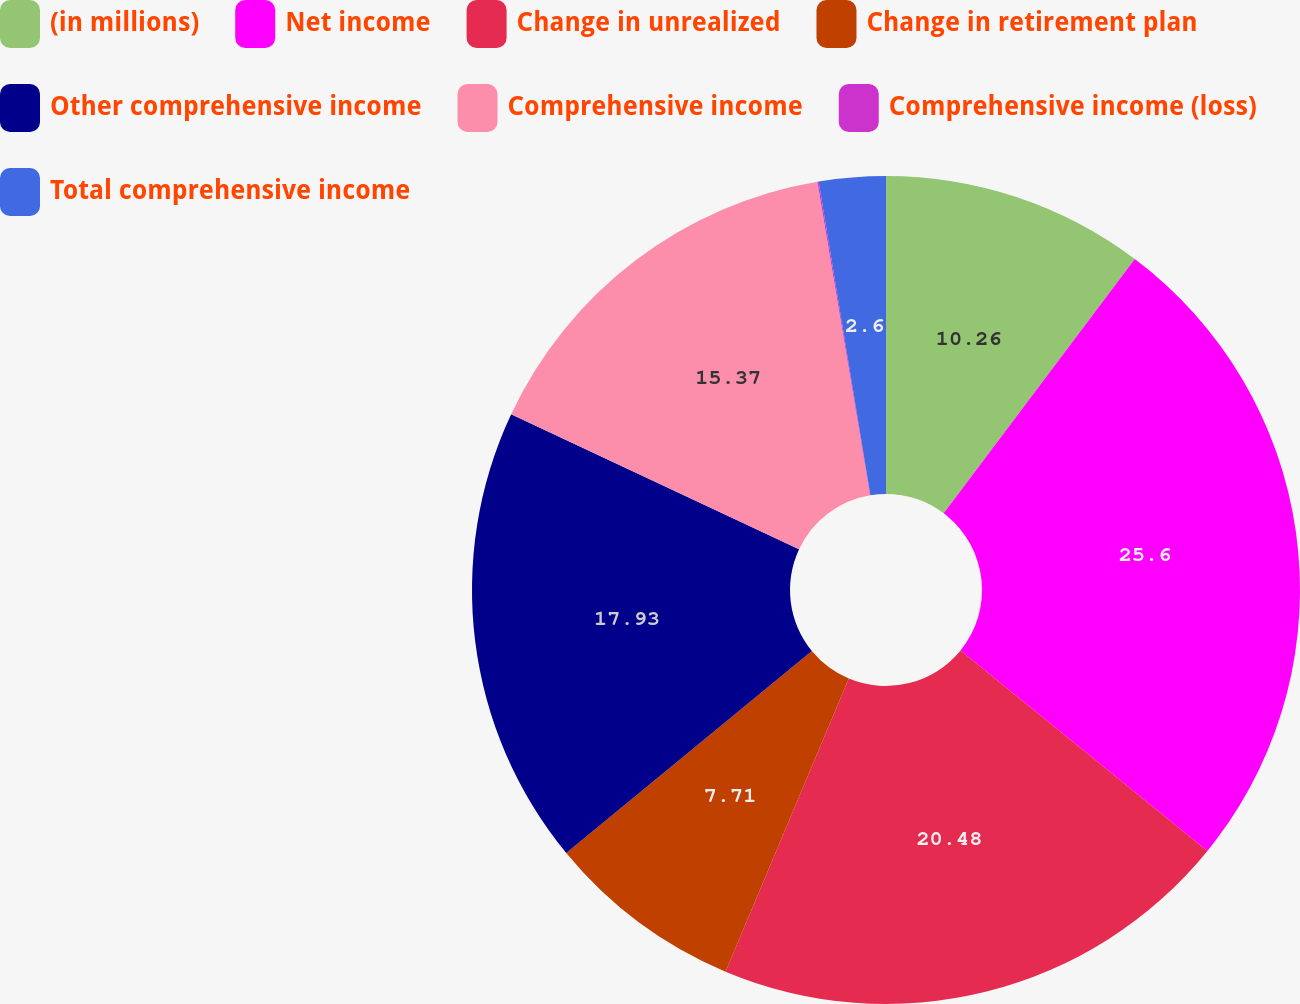<chart> <loc_0><loc_0><loc_500><loc_500><pie_chart><fcel>(in millions)<fcel>Net income<fcel>Change in unrealized<fcel>Change in retirement plan<fcel>Other comprehensive income<fcel>Comprehensive income<fcel>Comprehensive income (loss)<fcel>Total comprehensive income<nl><fcel>10.26%<fcel>25.59%<fcel>20.48%<fcel>7.71%<fcel>17.93%<fcel>15.37%<fcel>0.05%<fcel>2.6%<nl></chart> 